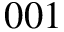Convert formula to latex. <formula><loc_0><loc_0><loc_500><loc_500>0 0 1</formula> 